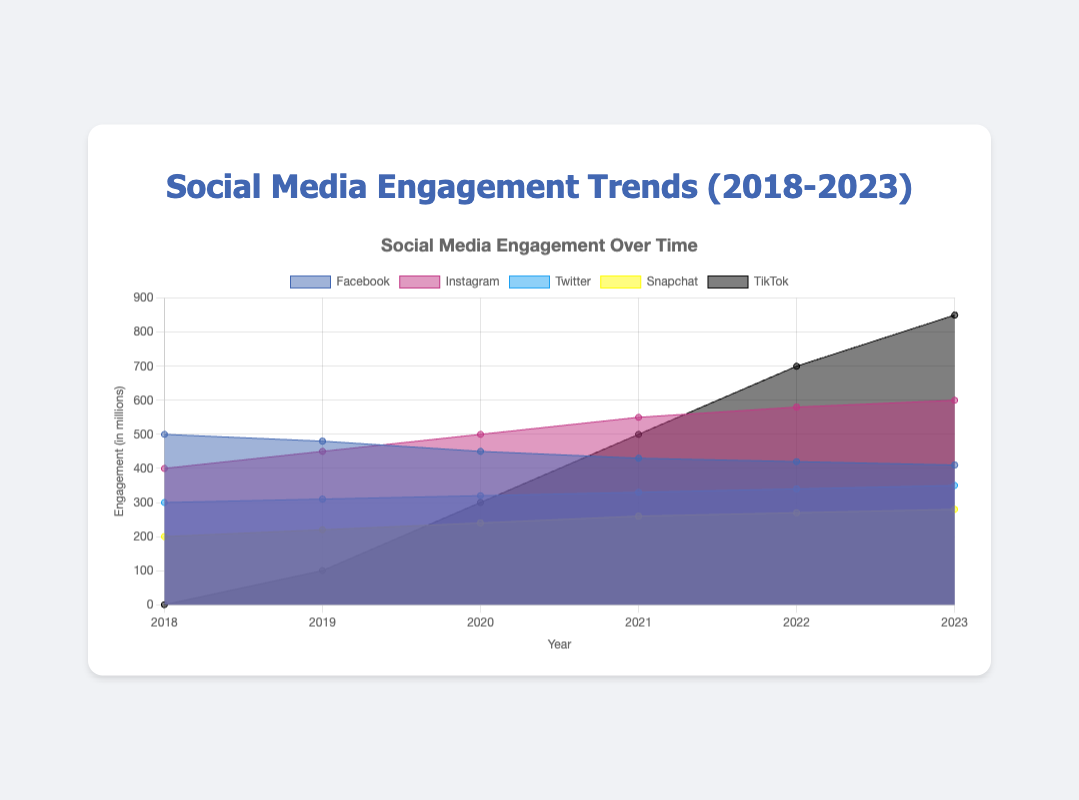What is the title of the figure? The title is located at the top center of the figure and explains the purpose or content of the chart.
Answer: Social Media Engagement Trends (2018-2023) What is the engagement value for TikTok in 2021? Locate the TikTok dataset and find the value corresponding to the year 2021.
Answer: 500 Which social media platform had the highest engagement in 2023? Compare the engagement values of all the platforms for the year 2023 and identify the highest value.
Answer: TikTok How did Facebook's engagement change from 2018 to 2023? Find the engagement values of Facebook for 2018 and 2023, then calculate the difference.
Answer: Decreased by 90 What is the average engagement for Twitter over the 6 years? Sum the engagement values for Twitter from 2018 to 2023, then divide by 6. (300 + 310 + 320 + 330 + 340 + 350) / 6 = 325
Answer: 325 Which platform showed the most significant growth in engagement from 2018 to 2023? Calculate the difference in engagement values for each platform between 2018 and 2023, then identify the highest growth.
Answer: TikTok Compare the engagement trends of Instagram and Facebook over the years 2018-2023. Which platform shows an upward trend? Analyze the engagement values of both Instagram and Facebook from 2018 to 2023. Instagram's values consistently increase, while Facebook's values decrease.
Answer: Instagram What is the combined engagement for Snapchat and Twitter in 2020? Add the engagement values of Snapchat and Twitter for the year 2020. 240 + 320 = 560
Answer: 560 In which year did Instagram's engagement surpass Facebook's engagement? Compare the engagement values of Instagram and Facebook for each year until Instagram's value exceeds Facebook's value.
Answer: 2020 What is the total engagement for all platforms in 2022? Sum the engagement values for all platforms for the year 2022. 420 + 580 + 340 + 270 + 700 = 2310
Answer: 2310 